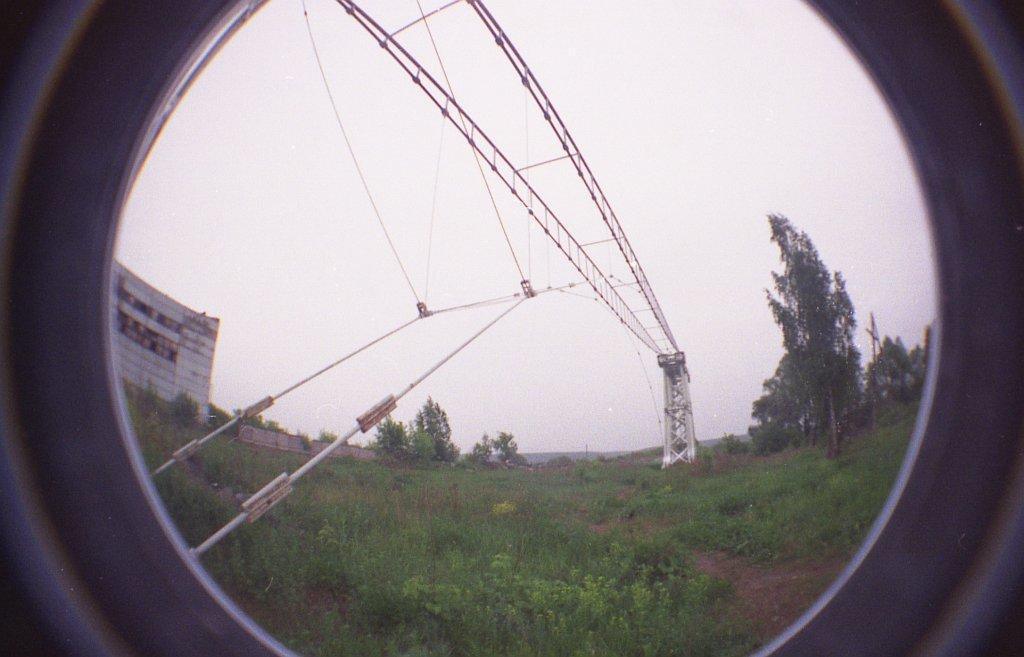Describe this image in one or two sentences. In this image, we can see the view from a glass. We can see the ground with some objects, grass, plants, trees. We can see a building and some metal objects. We can see the sky. 